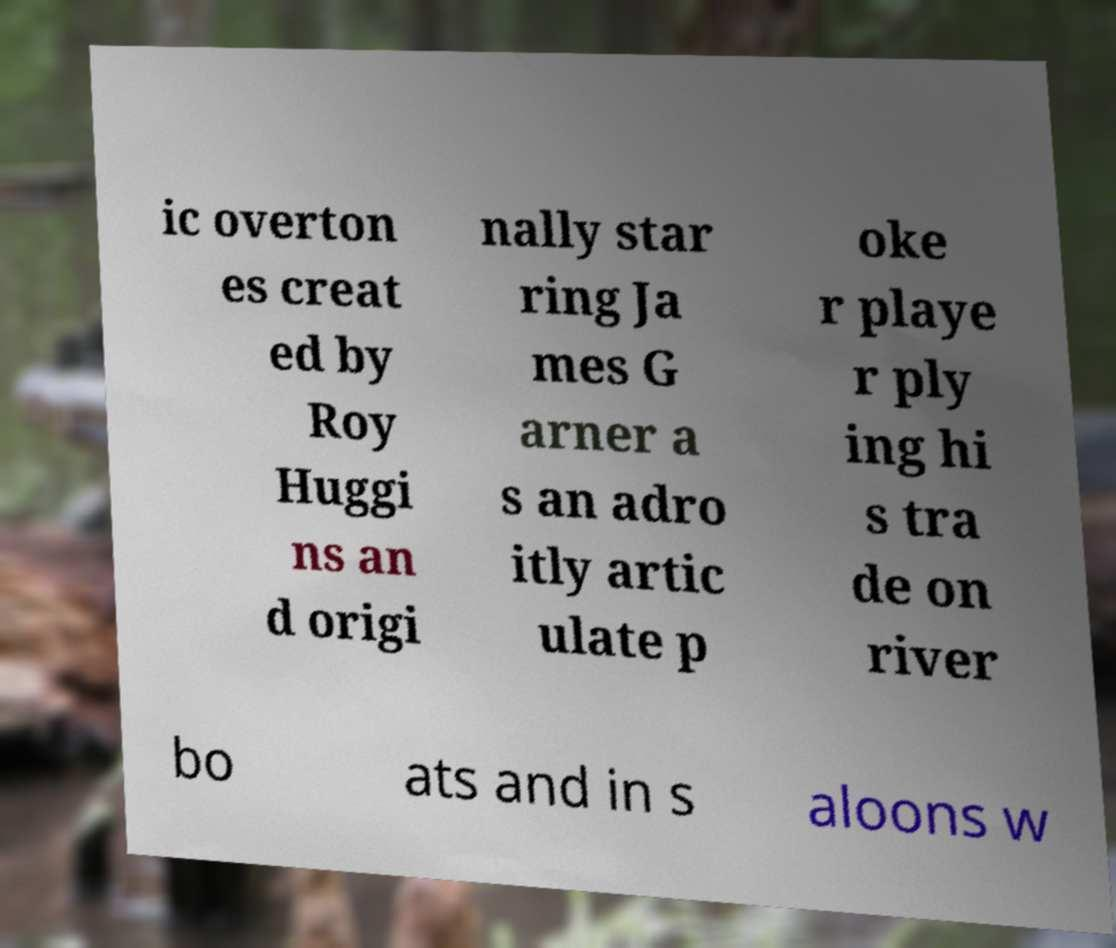For documentation purposes, I need the text within this image transcribed. Could you provide that? ic overton es creat ed by Roy Huggi ns an d origi nally star ring Ja mes G arner a s an adro itly artic ulate p oke r playe r ply ing hi s tra de on river bo ats and in s aloons w 